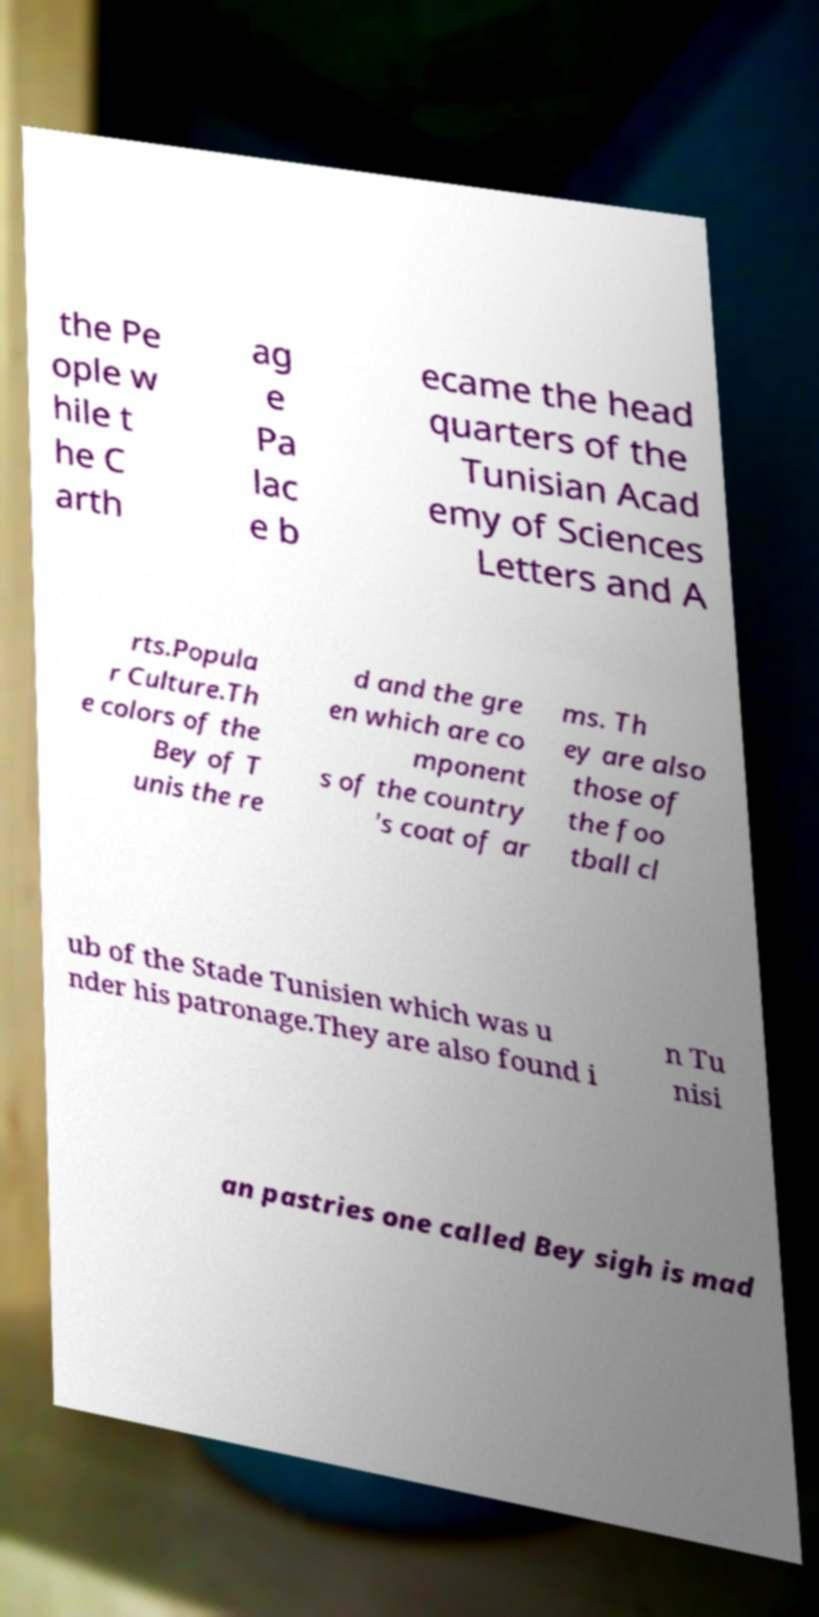There's text embedded in this image that I need extracted. Can you transcribe it verbatim? the Pe ople w hile t he C arth ag e Pa lac e b ecame the head quarters of the Tunisian Acad emy of Sciences Letters and A rts.Popula r Culture.Th e colors of the Bey of T unis the re d and the gre en which are co mponent s of the country 's coat of ar ms. Th ey are also those of the foo tball cl ub of the Stade Tunisien which was u nder his patronage.They are also found i n Tu nisi an pastries one called Bey sigh is mad 